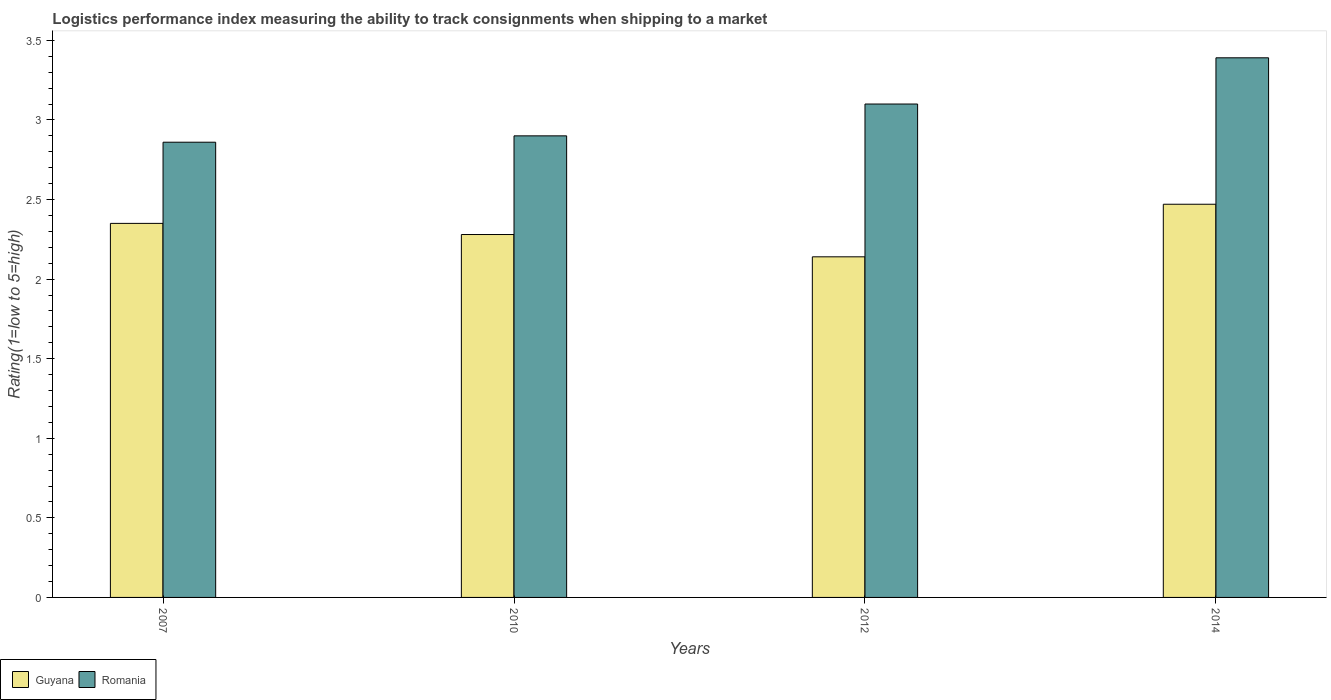Are the number of bars per tick equal to the number of legend labels?
Offer a very short reply. Yes. Are the number of bars on each tick of the X-axis equal?
Your answer should be very brief. Yes. How many bars are there on the 3rd tick from the right?
Offer a terse response. 2. In how many cases, is the number of bars for a given year not equal to the number of legend labels?
Provide a succinct answer. 0. Across all years, what is the maximum Logistic performance index in Guyana?
Ensure brevity in your answer.  2.47. Across all years, what is the minimum Logistic performance index in Guyana?
Give a very brief answer. 2.14. What is the total Logistic performance index in Romania in the graph?
Give a very brief answer. 12.25. What is the difference between the Logistic performance index in Guyana in 2007 and that in 2014?
Provide a succinct answer. -0.12. What is the difference between the Logistic performance index in Guyana in 2010 and the Logistic performance index in Romania in 2014?
Make the answer very short. -1.11. What is the average Logistic performance index in Romania per year?
Make the answer very short. 3.06. In the year 2012, what is the difference between the Logistic performance index in Romania and Logistic performance index in Guyana?
Ensure brevity in your answer.  0.96. In how many years, is the Logistic performance index in Guyana greater than 2.6?
Your answer should be very brief. 0. What is the ratio of the Logistic performance index in Guyana in 2007 to that in 2012?
Offer a terse response. 1.1. Is the Logistic performance index in Guyana in 2010 less than that in 2012?
Your response must be concise. No. What is the difference between the highest and the second highest Logistic performance index in Romania?
Your response must be concise. 0.29. What is the difference between the highest and the lowest Logistic performance index in Guyana?
Your response must be concise. 0.33. In how many years, is the Logistic performance index in Guyana greater than the average Logistic performance index in Guyana taken over all years?
Give a very brief answer. 2. Is the sum of the Logistic performance index in Guyana in 2010 and 2012 greater than the maximum Logistic performance index in Romania across all years?
Your answer should be very brief. Yes. What does the 1st bar from the left in 2007 represents?
Offer a very short reply. Guyana. What does the 1st bar from the right in 2012 represents?
Offer a very short reply. Romania. Are all the bars in the graph horizontal?
Your response must be concise. No. Are the values on the major ticks of Y-axis written in scientific E-notation?
Your answer should be very brief. No. Does the graph contain grids?
Your answer should be compact. No. What is the title of the graph?
Ensure brevity in your answer.  Logistics performance index measuring the ability to track consignments when shipping to a market. What is the label or title of the Y-axis?
Ensure brevity in your answer.  Rating(1=low to 5=high). What is the Rating(1=low to 5=high) in Guyana in 2007?
Make the answer very short. 2.35. What is the Rating(1=low to 5=high) in Romania in 2007?
Ensure brevity in your answer.  2.86. What is the Rating(1=low to 5=high) of Guyana in 2010?
Make the answer very short. 2.28. What is the Rating(1=low to 5=high) in Romania in 2010?
Offer a terse response. 2.9. What is the Rating(1=low to 5=high) in Guyana in 2012?
Your answer should be very brief. 2.14. What is the Rating(1=low to 5=high) of Romania in 2012?
Provide a succinct answer. 3.1. What is the Rating(1=low to 5=high) of Guyana in 2014?
Your answer should be very brief. 2.47. What is the Rating(1=low to 5=high) in Romania in 2014?
Your answer should be compact. 3.39. Across all years, what is the maximum Rating(1=low to 5=high) of Guyana?
Ensure brevity in your answer.  2.47. Across all years, what is the maximum Rating(1=low to 5=high) in Romania?
Make the answer very short. 3.39. Across all years, what is the minimum Rating(1=low to 5=high) in Guyana?
Offer a very short reply. 2.14. Across all years, what is the minimum Rating(1=low to 5=high) in Romania?
Offer a very short reply. 2.86. What is the total Rating(1=low to 5=high) of Guyana in the graph?
Offer a terse response. 9.24. What is the total Rating(1=low to 5=high) of Romania in the graph?
Keep it short and to the point. 12.25. What is the difference between the Rating(1=low to 5=high) in Guyana in 2007 and that in 2010?
Your response must be concise. 0.07. What is the difference between the Rating(1=low to 5=high) of Romania in 2007 and that in 2010?
Provide a short and direct response. -0.04. What is the difference between the Rating(1=low to 5=high) in Guyana in 2007 and that in 2012?
Provide a succinct answer. 0.21. What is the difference between the Rating(1=low to 5=high) of Romania in 2007 and that in 2012?
Provide a short and direct response. -0.24. What is the difference between the Rating(1=low to 5=high) of Guyana in 2007 and that in 2014?
Offer a very short reply. -0.12. What is the difference between the Rating(1=low to 5=high) of Romania in 2007 and that in 2014?
Make the answer very short. -0.53. What is the difference between the Rating(1=low to 5=high) in Guyana in 2010 and that in 2012?
Make the answer very short. 0.14. What is the difference between the Rating(1=low to 5=high) of Guyana in 2010 and that in 2014?
Make the answer very short. -0.19. What is the difference between the Rating(1=low to 5=high) of Romania in 2010 and that in 2014?
Offer a very short reply. -0.49. What is the difference between the Rating(1=low to 5=high) in Guyana in 2012 and that in 2014?
Your answer should be compact. -0.33. What is the difference between the Rating(1=low to 5=high) of Romania in 2012 and that in 2014?
Ensure brevity in your answer.  -0.29. What is the difference between the Rating(1=low to 5=high) of Guyana in 2007 and the Rating(1=low to 5=high) of Romania in 2010?
Make the answer very short. -0.55. What is the difference between the Rating(1=low to 5=high) of Guyana in 2007 and the Rating(1=low to 5=high) of Romania in 2012?
Your answer should be compact. -0.75. What is the difference between the Rating(1=low to 5=high) of Guyana in 2007 and the Rating(1=low to 5=high) of Romania in 2014?
Give a very brief answer. -1.04. What is the difference between the Rating(1=low to 5=high) in Guyana in 2010 and the Rating(1=low to 5=high) in Romania in 2012?
Offer a very short reply. -0.82. What is the difference between the Rating(1=low to 5=high) of Guyana in 2010 and the Rating(1=low to 5=high) of Romania in 2014?
Ensure brevity in your answer.  -1.11. What is the difference between the Rating(1=low to 5=high) of Guyana in 2012 and the Rating(1=low to 5=high) of Romania in 2014?
Make the answer very short. -1.25. What is the average Rating(1=low to 5=high) in Guyana per year?
Your answer should be very brief. 2.31. What is the average Rating(1=low to 5=high) of Romania per year?
Keep it short and to the point. 3.06. In the year 2007, what is the difference between the Rating(1=low to 5=high) of Guyana and Rating(1=low to 5=high) of Romania?
Make the answer very short. -0.51. In the year 2010, what is the difference between the Rating(1=low to 5=high) in Guyana and Rating(1=low to 5=high) in Romania?
Give a very brief answer. -0.62. In the year 2012, what is the difference between the Rating(1=low to 5=high) of Guyana and Rating(1=low to 5=high) of Romania?
Your response must be concise. -0.96. In the year 2014, what is the difference between the Rating(1=low to 5=high) of Guyana and Rating(1=low to 5=high) of Romania?
Ensure brevity in your answer.  -0.92. What is the ratio of the Rating(1=low to 5=high) of Guyana in 2007 to that in 2010?
Ensure brevity in your answer.  1.03. What is the ratio of the Rating(1=low to 5=high) in Romania in 2007 to that in 2010?
Your answer should be very brief. 0.99. What is the ratio of the Rating(1=low to 5=high) of Guyana in 2007 to that in 2012?
Keep it short and to the point. 1.1. What is the ratio of the Rating(1=low to 5=high) of Romania in 2007 to that in 2012?
Your answer should be very brief. 0.92. What is the ratio of the Rating(1=low to 5=high) of Guyana in 2007 to that in 2014?
Keep it short and to the point. 0.95. What is the ratio of the Rating(1=low to 5=high) in Romania in 2007 to that in 2014?
Ensure brevity in your answer.  0.84. What is the ratio of the Rating(1=low to 5=high) of Guyana in 2010 to that in 2012?
Make the answer very short. 1.07. What is the ratio of the Rating(1=low to 5=high) of Romania in 2010 to that in 2012?
Offer a very short reply. 0.94. What is the ratio of the Rating(1=low to 5=high) in Guyana in 2010 to that in 2014?
Give a very brief answer. 0.92. What is the ratio of the Rating(1=low to 5=high) of Romania in 2010 to that in 2014?
Provide a succinct answer. 0.86. What is the ratio of the Rating(1=low to 5=high) of Guyana in 2012 to that in 2014?
Provide a succinct answer. 0.87. What is the ratio of the Rating(1=low to 5=high) in Romania in 2012 to that in 2014?
Your answer should be very brief. 0.91. What is the difference between the highest and the second highest Rating(1=low to 5=high) in Guyana?
Give a very brief answer. 0.12. What is the difference between the highest and the second highest Rating(1=low to 5=high) in Romania?
Your answer should be very brief. 0.29. What is the difference between the highest and the lowest Rating(1=low to 5=high) in Guyana?
Give a very brief answer. 0.33. What is the difference between the highest and the lowest Rating(1=low to 5=high) in Romania?
Offer a terse response. 0.53. 